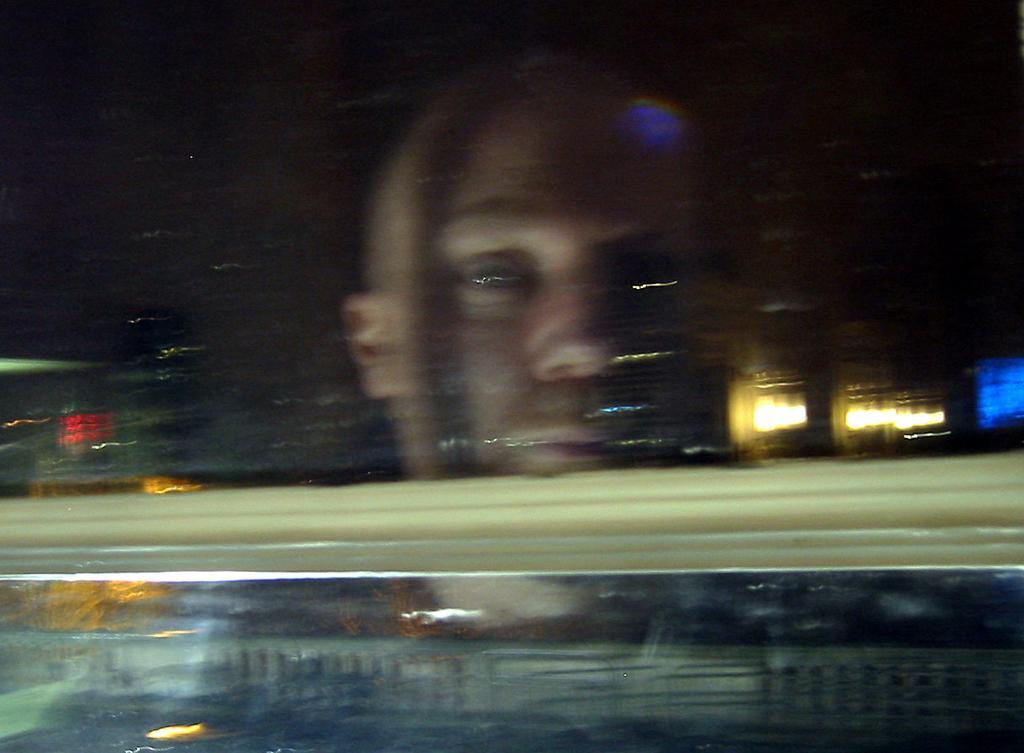Could you give a brief overview of what you see in this image? In this picture there is a guy behind the glass and the background area is blurred. 